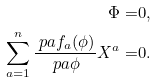<formula> <loc_0><loc_0><loc_500><loc_500>\Phi = & 0 , \\ \sum _ { a = 1 } ^ { n } \frac { \ p a f _ { a } ( \phi ) } { \ p a \phi } X ^ { a } = & 0 .</formula> 